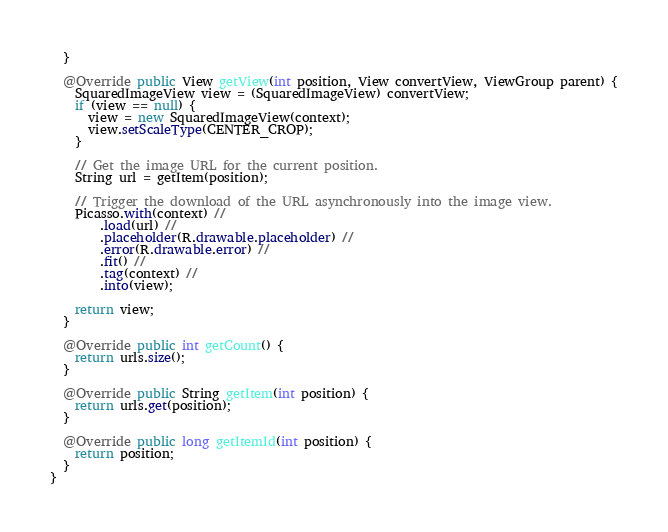Convert code to text. <code><loc_0><loc_0><loc_500><loc_500><_Java_>  }

  @Override public View getView(int position, View convertView, ViewGroup parent) {
    SquaredImageView view = (SquaredImageView) convertView;
    if (view == null) {
      view = new SquaredImageView(context);
      view.setScaleType(CENTER_CROP);
    }

    // Get the image URL for the current position.
    String url = getItem(position);

    // Trigger the download of the URL asynchronously into the image view.
    Picasso.with(context) //
        .load(url) //
        .placeholder(R.drawable.placeholder) //
        .error(R.drawable.error) //
        .fit() //
        .tag(context) //
        .into(view);

    return view;
  }

  @Override public int getCount() {
    return urls.size();
  }

  @Override public String getItem(int position) {
    return urls.get(position);
  }

  @Override public long getItemId(int position) {
    return position;
  }
}
</code> 